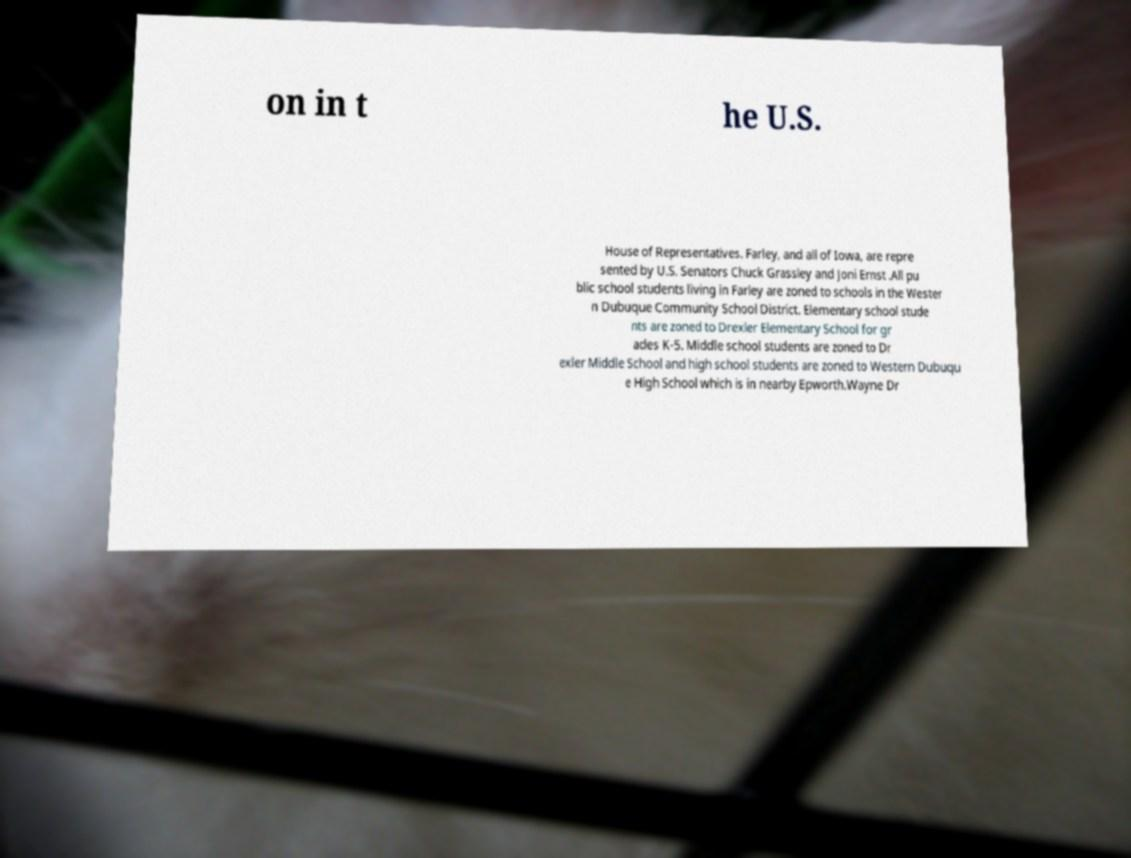Could you extract and type out the text from this image? on in t he U.S. House of Representatives. Farley, and all of Iowa, are repre sented by U.S. Senators Chuck Grassley and Joni Ernst .All pu blic school students living in Farley are zoned to schools in the Wester n Dubuque Community School District. Elementary school stude nts are zoned to Drexler Elementary School for gr ades K-5. Middle school students are zoned to Dr exler Middle School and high school students are zoned to Western Dubuqu e High School which is in nearby Epworth.Wayne Dr 